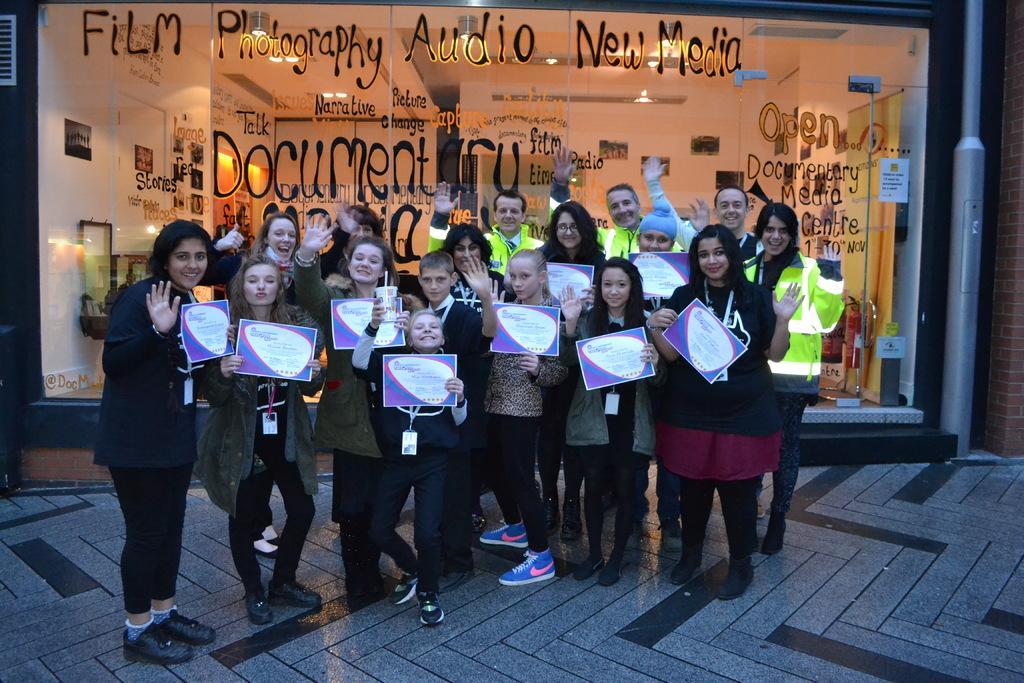Please provide a concise description of this image. In this image there are few people standing wearing winter clothes. They are holding certificates. They all are smiling. Few are waving their hands. In the background there is a glass wall. On the wall few text. Through the wall we can see the interior of the building. 